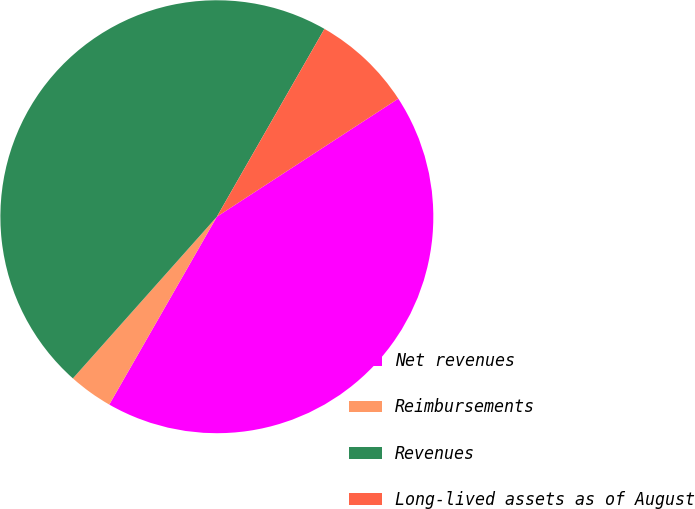Convert chart to OTSL. <chart><loc_0><loc_0><loc_500><loc_500><pie_chart><fcel>Net revenues<fcel>Reimbursements<fcel>Revenues<fcel>Long-lived assets as of August<nl><fcel>42.46%<fcel>3.3%<fcel>46.7%<fcel>7.54%<nl></chart> 